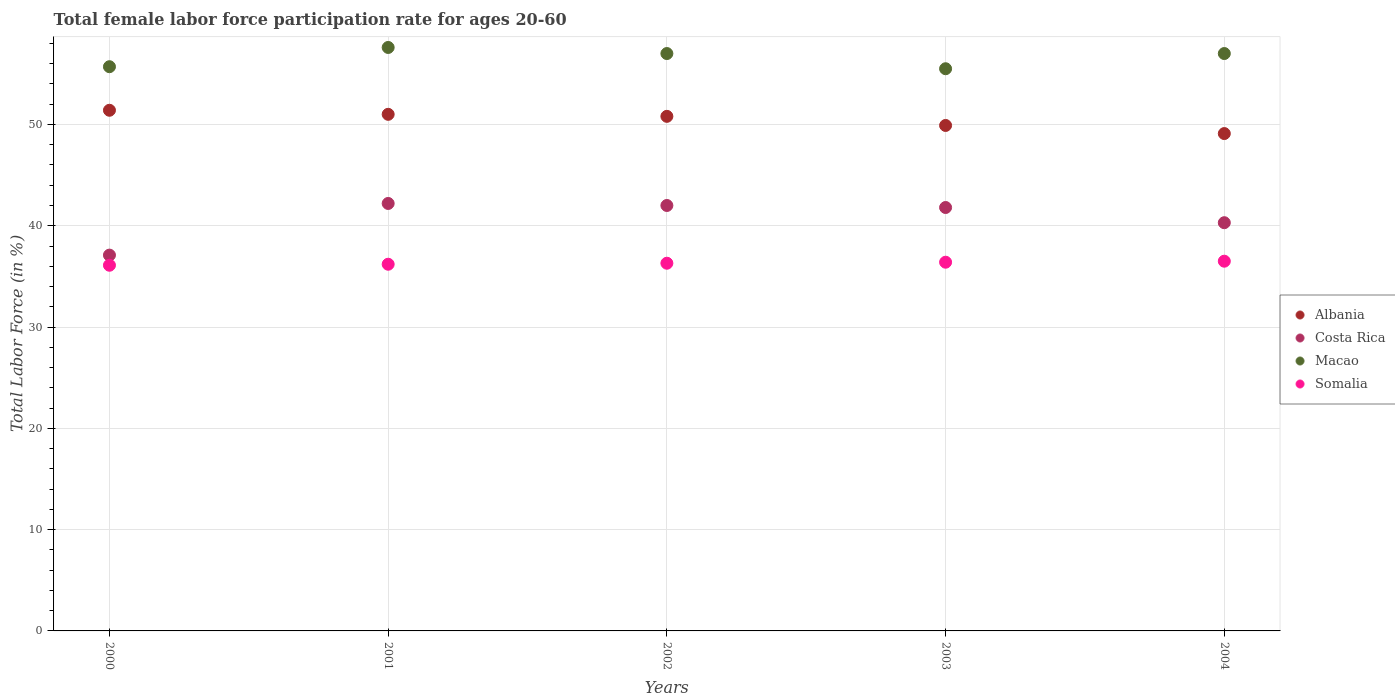Is the number of dotlines equal to the number of legend labels?
Provide a short and direct response. Yes. What is the female labor force participation rate in Costa Rica in 2004?
Provide a short and direct response. 40.3. Across all years, what is the maximum female labor force participation rate in Somalia?
Your answer should be very brief. 36.5. Across all years, what is the minimum female labor force participation rate in Macao?
Your answer should be compact. 55.5. What is the total female labor force participation rate in Albania in the graph?
Provide a succinct answer. 252.2. What is the difference between the female labor force participation rate in Costa Rica in 2002 and that in 2003?
Make the answer very short. 0.2. What is the difference between the female labor force participation rate in Albania in 2004 and the female labor force participation rate in Costa Rica in 2002?
Ensure brevity in your answer.  7.1. What is the average female labor force participation rate in Somalia per year?
Give a very brief answer. 36.3. In the year 2000, what is the difference between the female labor force participation rate in Somalia and female labor force participation rate in Albania?
Offer a terse response. -15.3. In how many years, is the female labor force participation rate in Albania greater than 56 %?
Your answer should be compact. 0. What is the ratio of the female labor force participation rate in Costa Rica in 2001 to that in 2003?
Keep it short and to the point. 1.01. Is the difference between the female labor force participation rate in Somalia in 2002 and 2003 greater than the difference between the female labor force participation rate in Albania in 2002 and 2003?
Ensure brevity in your answer.  No. What is the difference between the highest and the second highest female labor force participation rate in Somalia?
Ensure brevity in your answer.  0.1. What is the difference between the highest and the lowest female labor force participation rate in Albania?
Offer a terse response. 2.3. Is it the case that in every year, the sum of the female labor force participation rate in Albania and female labor force participation rate in Macao  is greater than the female labor force participation rate in Costa Rica?
Make the answer very short. Yes. Is the female labor force participation rate in Albania strictly greater than the female labor force participation rate in Costa Rica over the years?
Provide a short and direct response. Yes. How many years are there in the graph?
Ensure brevity in your answer.  5. What is the difference between two consecutive major ticks on the Y-axis?
Give a very brief answer. 10. Does the graph contain any zero values?
Offer a terse response. No. Where does the legend appear in the graph?
Provide a short and direct response. Center right. How many legend labels are there?
Keep it short and to the point. 4. How are the legend labels stacked?
Offer a very short reply. Vertical. What is the title of the graph?
Ensure brevity in your answer.  Total female labor force participation rate for ages 20-60. Does "Belgium" appear as one of the legend labels in the graph?
Your answer should be very brief. No. What is the label or title of the X-axis?
Your answer should be compact. Years. What is the Total Labor Force (in %) of Albania in 2000?
Offer a terse response. 51.4. What is the Total Labor Force (in %) of Costa Rica in 2000?
Keep it short and to the point. 37.1. What is the Total Labor Force (in %) in Macao in 2000?
Provide a succinct answer. 55.7. What is the Total Labor Force (in %) of Somalia in 2000?
Keep it short and to the point. 36.1. What is the Total Labor Force (in %) of Albania in 2001?
Offer a very short reply. 51. What is the Total Labor Force (in %) in Costa Rica in 2001?
Your response must be concise. 42.2. What is the Total Labor Force (in %) of Macao in 2001?
Provide a succinct answer. 57.6. What is the Total Labor Force (in %) in Somalia in 2001?
Provide a short and direct response. 36.2. What is the Total Labor Force (in %) in Albania in 2002?
Your response must be concise. 50.8. What is the Total Labor Force (in %) in Macao in 2002?
Give a very brief answer. 57. What is the Total Labor Force (in %) in Somalia in 2002?
Keep it short and to the point. 36.3. What is the Total Labor Force (in %) in Albania in 2003?
Keep it short and to the point. 49.9. What is the Total Labor Force (in %) in Costa Rica in 2003?
Keep it short and to the point. 41.8. What is the Total Labor Force (in %) in Macao in 2003?
Provide a short and direct response. 55.5. What is the Total Labor Force (in %) in Somalia in 2003?
Provide a succinct answer. 36.4. What is the Total Labor Force (in %) of Albania in 2004?
Provide a succinct answer. 49.1. What is the Total Labor Force (in %) in Costa Rica in 2004?
Your answer should be compact. 40.3. What is the Total Labor Force (in %) of Somalia in 2004?
Offer a very short reply. 36.5. Across all years, what is the maximum Total Labor Force (in %) of Albania?
Provide a short and direct response. 51.4. Across all years, what is the maximum Total Labor Force (in %) of Costa Rica?
Give a very brief answer. 42.2. Across all years, what is the maximum Total Labor Force (in %) of Macao?
Offer a very short reply. 57.6. Across all years, what is the maximum Total Labor Force (in %) in Somalia?
Your answer should be compact. 36.5. Across all years, what is the minimum Total Labor Force (in %) of Albania?
Give a very brief answer. 49.1. Across all years, what is the minimum Total Labor Force (in %) in Costa Rica?
Your answer should be compact. 37.1. Across all years, what is the minimum Total Labor Force (in %) in Macao?
Your answer should be compact. 55.5. Across all years, what is the minimum Total Labor Force (in %) in Somalia?
Offer a terse response. 36.1. What is the total Total Labor Force (in %) of Albania in the graph?
Your answer should be compact. 252.2. What is the total Total Labor Force (in %) of Costa Rica in the graph?
Your answer should be very brief. 203.4. What is the total Total Labor Force (in %) in Macao in the graph?
Offer a terse response. 282.8. What is the total Total Labor Force (in %) in Somalia in the graph?
Offer a terse response. 181.5. What is the difference between the Total Labor Force (in %) in Albania in 2000 and that in 2001?
Offer a terse response. 0.4. What is the difference between the Total Labor Force (in %) of Costa Rica in 2000 and that in 2001?
Your answer should be compact. -5.1. What is the difference between the Total Labor Force (in %) of Macao in 2000 and that in 2001?
Provide a succinct answer. -1.9. What is the difference between the Total Labor Force (in %) in Somalia in 2000 and that in 2001?
Your answer should be very brief. -0.1. What is the difference between the Total Labor Force (in %) of Albania in 2000 and that in 2002?
Your answer should be very brief. 0.6. What is the difference between the Total Labor Force (in %) in Somalia in 2000 and that in 2002?
Your answer should be compact. -0.2. What is the difference between the Total Labor Force (in %) of Costa Rica in 2000 and that in 2003?
Provide a short and direct response. -4.7. What is the difference between the Total Labor Force (in %) of Macao in 2000 and that in 2003?
Give a very brief answer. 0.2. What is the difference between the Total Labor Force (in %) of Albania in 2000 and that in 2004?
Your answer should be very brief. 2.3. What is the difference between the Total Labor Force (in %) of Costa Rica in 2000 and that in 2004?
Make the answer very short. -3.2. What is the difference between the Total Labor Force (in %) in Macao in 2000 and that in 2004?
Offer a terse response. -1.3. What is the difference between the Total Labor Force (in %) of Somalia in 2000 and that in 2004?
Ensure brevity in your answer.  -0.4. What is the difference between the Total Labor Force (in %) in Albania in 2001 and that in 2002?
Make the answer very short. 0.2. What is the difference between the Total Labor Force (in %) in Macao in 2001 and that in 2002?
Ensure brevity in your answer.  0.6. What is the difference between the Total Labor Force (in %) of Albania in 2001 and that in 2003?
Provide a succinct answer. 1.1. What is the difference between the Total Labor Force (in %) of Costa Rica in 2001 and that in 2003?
Make the answer very short. 0.4. What is the difference between the Total Labor Force (in %) of Macao in 2001 and that in 2003?
Your response must be concise. 2.1. What is the difference between the Total Labor Force (in %) of Somalia in 2001 and that in 2003?
Ensure brevity in your answer.  -0.2. What is the difference between the Total Labor Force (in %) of Costa Rica in 2001 and that in 2004?
Provide a short and direct response. 1.9. What is the difference between the Total Labor Force (in %) of Macao in 2001 and that in 2004?
Make the answer very short. 0.6. What is the difference between the Total Labor Force (in %) of Albania in 2002 and that in 2003?
Your response must be concise. 0.9. What is the difference between the Total Labor Force (in %) in Macao in 2002 and that in 2003?
Provide a succinct answer. 1.5. What is the difference between the Total Labor Force (in %) in Costa Rica in 2002 and that in 2004?
Your answer should be compact. 1.7. What is the difference between the Total Labor Force (in %) of Macao in 2002 and that in 2004?
Your answer should be compact. 0. What is the difference between the Total Labor Force (in %) in Albania in 2003 and that in 2004?
Make the answer very short. 0.8. What is the difference between the Total Labor Force (in %) in Somalia in 2003 and that in 2004?
Offer a terse response. -0.1. What is the difference between the Total Labor Force (in %) in Albania in 2000 and the Total Labor Force (in %) in Somalia in 2001?
Your answer should be compact. 15.2. What is the difference between the Total Labor Force (in %) of Costa Rica in 2000 and the Total Labor Force (in %) of Macao in 2001?
Your answer should be very brief. -20.5. What is the difference between the Total Labor Force (in %) of Costa Rica in 2000 and the Total Labor Force (in %) of Somalia in 2001?
Give a very brief answer. 0.9. What is the difference between the Total Labor Force (in %) of Albania in 2000 and the Total Labor Force (in %) of Costa Rica in 2002?
Provide a short and direct response. 9.4. What is the difference between the Total Labor Force (in %) of Albania in 2000 and the Total Labor Force (in %) of Macao in 2002?
Offer a very short reply. -5.6. What is the difference between the Total Labor Force (in %) in Costa Rica in 2000 and the Total Labor Force (in %) in Macao in 2002?
Your response must be concise. -19.9. What is the difference between the Total Labor Force (in %) in Macao in 2000 and the Total Labor Force (in %) in Somalia in 2002?
Your answer should be very brief. 19.4. What is the difference between the Total Labor Force (in %) of Albania in 2000 and the Total Labor Force (in %) of Costa Rica in 2003?
Provide a succinct answer. 9.6. What is the difference between the Total Labor Force (in %) of Albania in 2000 and the Total Labor Force (in %) of Macao in 2003?
Keep it short and to the point. -4.1. What is the difference between the Total Labor Force (in %) of Costa Rica in 2000 and the Total Labor Force (in %) of Macao in 2003?
Keep it short and to the point. -18.4. What is the difference between the Total Labor Force (in %) of Costa Rica in 2000 and the Total Labor Force (in %) of Somalia in 2003?
Offer a terse response. 0.7. What is the difference between the Total Labor Force (in %) in Macao in 2000 and the Total Labor Force (in %) in Somalia in 2003?
Offer a terse response. 19.3. What is the difference between the Total Labor Force (in %) of Albania in 2000 and the Total Labor Force (in %) of Costa Rica in 2004?
Offer a very short reply. 11.1. What is the difference between the Total Labor Force (in %) of Costa Rica in 2000 and the Total Labor Force (in %) of Macao in 2004?
Offer a terse response. -19.9. What is the difference between the Total Labor Force (in %) of Costa Rica in 2000 and the Total Labor Force (in %) of Somalia in 2004?
Your answer should be compact. 0.6. What is the difference between the Total Labor Force (in %) of Albania in 2001 and the Total Labor Force (in %) of Somalia in 2002?
Keep it short and to the point. 14.7. What is the difference between the Total Labor Force (in %) of Costa Rica in 2001 and the Total Labor Force (in %) of Macao in 2002?
Offer a very short reply. -14.8. What is the difference between the Total Labor Force (in %) in Macao in 2001 and the Total Labor Force (in %) in Somalia in 2002?
Provide a succinct answer. 21.3. What is the difference between the Total Labor Force (in %) in Albania in 2001 and the Total Labor Force (in %) in Costa Rica in 2003?
Provide a short and direct response. 9.2. What is the difference between the Total Labor Force (in %) of Albania in 2001 and the Total Labor Force (in %) of Somalia in 2003?
Your response must be concise. 14.6. What is the difference between the Total Labor Force (in %) in Costa Rica in 2001 and the Total Labor Force (in %) in Macao in 2003?
Ensure brevity in your answer.  -13.3. What is the difference between the Total Labor Force (in %) of Costa Rica in 2001 and the Total Labor Force (in %) of Somalia in 2003?
Offer a terse response. 5.8. What is the difference between the Total Labor Force (in %) in Macao in 2001 and the Total Labor Force (in %) in Somalia in 2003?
Your answer should be compact. 21.2. What is the difference between the Total Labor Force (in %) of Albania in 2001 and the Total Labor Force (in %) of Costa Rica in 2004?
Make the answer very short. 10.7. What is the difference between the Total Labor Force (in %) of Albania in 2001 and the Total Labor Force (in %) of Macao in 2004?
Provide a succinct answer. -6. What is the difference between the Total Labor Force (in %) in Albania in 2001 and the Total Labor Force (in %) in Somalia in 2004?
Your answer should be very brief. 14.5. What is the difference between the Total Labor Force (in %) in Costa Rica in 2001 and the Total Labor Force (in %) in Macao in 2004?
Ensure brevity in your answer.  -14.8. What is the difference between the Total Labor Force (in %) in Costa Rica in 2001 and the Total Labor Force (in %) in Somalia in 2004?
Provide a succinct answer. 5.7. What is the difference between the Total Labor Force (in %) of Macao in 2001 and the Total Labor Force (in %) of Somalia in 2004?
Offer a terse response. 21.1. What is the difference between the Total Labor Force (in %) in Albania in 2002 and the Total Labor Force (in %) in Costa Rica in 2003?
Provide a short and direct response. 9. What is the difference between the Total Labor Force (in %) of Albania in 2002 and the Total Labor Force (in %) of Macao in 2003?
Provide a short and direct response. -4.7. What is the difference between the Total Labor Force (in %) in Macao in 2002 and the Total Labor Force (in %) in Somalia in 2003?
Provide a short and direct response. 20.6. What is the difference between the Total Labor Force (in %) in Albania in 2002 and the Total Labor Force (in %) in Macao in 2004?
Ensure brevity in your answer.  -6.2. What is the difference between the Total Labor Force (in %) in Albania in 2002 and the Total Labor Force (in %) in Somalia in 2004?
Ensure brevity in your answer.  14.3. What is the difference between the Total Labor Force (in %) of Costa Rica in 2002 and the Total Labor Force (in %) of Macao in 2004?
Give a very brief answer. -15. What is the difference between the Total Labor Force (in %) of Macao in 2002 and the Total Labor Force (in %) of Somalia in 2004?
Your answer should be compact. 20.5. What is the difference between the Total Labor Force (in %) in Costa Rica in 2003 and the Total Labor Force (in %) in Macao in 2004?
Make the answer very short. -15.2. What is the average Total Labor Force (in %) of Albania per year?
Your response must be concise. 50.44. What is the average Total Labor Force (in %) of Costa Rica per year?
Your answer should be very brief. 40.68. What is the average Total Labor Force (in %) in Macao per year?
Provide a short and direct response. 56.56. What is the average Total Labor Force (in %) of Somalia per year?
Keep it short and to the point. 36.3. In the year 2000, what is the difference between the Total Labor Force (in %) of Albania and Total Labor Force (in %) of Costa Rica?
Your response must be concise. 14.3. In the year 2000, what is the difference between the Total Labor Force (in %) in Albania and Total Labor Force (in %) in Somalia?
Your answer should be compact. 15.3. In the year 2000, what is the difference between the Total Labor Force (in %) in Costa Rica and Total Labor Force (in %) in Macao?
Offer a terse response. -18.6. In the year 2000, what is the difference between the Total Labor Force (in %) of Costa Rica and Total Labor Force (in %) of Somalia?
Give a very brief answer. 1. In the year 2000, what is the difference between the Total Labor Force (in %) in Macao and Total Labor Force (in %) in Somalia?
Provide a succinct answer. 19.6. In the year 2001, what is the difference between the Total Labor Force (in %) of Albania and Total Labor Force (in %) of Macao?
Provide a short and direct response. -6.6. In the year 2001, what is the difference between the Total Labor Force (in %) in Albania and Total Labor Force (in %) in Somalia?
Keep it short and to the point. 14.8. In the year 2001, what is the difference between the Total Labor Force (in %) of Costa Rica and Total Labor Force (in %) of Macao?
Offer a terse response. -15.4. In the year 2001, what is the difference between the Total Labor Force (in %) in Macao and Total Labor Force (in %) in Somalia?
Offer a terse response. 21.4. In the year 2002, what is the difference between the Total Labor Force (in %) in Albania and Total Labor Force (in %) in Macao?
Give a very brief answer. -6.2. In the year 2002, what is the difference between the Total Labor Force (in %) in Albania and Total Labor Force (in %) in Somalia?
Provide a short and direct response. 14.5. In the year 2002, what is the difference between the Total Labor Force (in %) of Macao and Total Labor Force (in %) of Somalia?
Provide a succinct answer. 20.7. In the year 2003, what is the difference between the Total Labor Force (in %) of Costa Rica and Total Labor Force (in %) of Macao?
Ensure brevity in your answer.  -13.7. In the year 2004, what is the difference between the Total Labor Force (in %) of Costa Rica and Total Labor Force (in %) of Macao?
Give a very brief answer. -16.7. In the year 2004, what is the difference between the Total Labor Force (in %) of Macao and Total Labor Force (in %) of Somalia?
Make the answer very short. 20.5. What is the ratio of the Total Labor Force (in %) of Costa Rica in 2000 to that in 2001?
Keep it short and to the point. 0.88. What is the ratio of the Total Labor Force (in %) of Macao in 2000 to that in 2001?
Provide a succinct answer. 0.97. What is the ratio of the Total Labor Force (in %) of Albania in 2000 to that in 2002?
Provide a short and direct response. 1.01. What is the ratio of the Total Labor Force (in %) of Costa Rica in 2000 to that in 2002?
Keep it short and to the point. 0.88. What is the ratio of the Total Labor Force (in %) of Macao in 2000 to that in 2002?
Provide a short and direct response. 0.98. What is the ratio of the Total Labor Force (in %) of Somalia in 2000 to that in 2002?
Ensure brevity in your answer.  0.99. What is the ratio of the Total Labor Force (in %) of Albania in 2000 to that in 2003?
Give a very brief answer. 1.03. What is the ratio of the Total Labor Force (in %) of Costa Rica in 2000 to that in 2003?
Provide a succinct answer. 0.89. What is the ratio of the Total Labor Force (in %) in Macao in 2000 to that in 2003?
Offer a terse response. 1. What is the ratio of the Total Labor Force (in %) of Albania in 2000 to that in 2004?
Make the answer very short. 1.05. What is the ratio of the Total Labor Force (in %) in Costa Rica in 2000 to that in 2004?
Provide a succinct answer. 0.92. What is the ratio of the Total Labor Force (in %) of Macao in 2000 to that in 2004?
Give a very brief answer. 0.98. What is the ratio of the Total Labor Force (in %) in Albania in 2001 to that in 2002?
Provide a short and direct response. 1. What is the ratio of the Total Labor Force (in %) of Macao in 2001 to that in 2002?
Ensure brevity in your answer.  1.01. What is the ratio of the Total Labor Force (in %) in Albania in 2001 to that in 2003?
Provide a succinct answer. 1.02. What is the ratio of the Total Labor Force (in %) of Costa Rica in 2001 to that in 2003?
Keep it short and to the point. 1.01. What is the ratio of the Total Labor Force (in %) in Macao in 2001 to that in 2003?
Provide a succinct answer. 1.04. What is the ratio of the Total Labor Force (in %) of Somalia in 2001 to that in 2003?
Offer a terse response. 0.99. What is the ratio of the Total Labor Force (in %) of Albania in 2001 to that in 2004?
Offer a terse response. 1.04. What is the ratio of the Total Labor Force (in %) in Costa Rica in 2001 to that in 2004?
Your answer should be compact. 1.05. What is the ratio of the Total Labor Force (in %) in Macao in 2001 to that in 2004?
Provide a short and direct response. 1.01. What is the ratio of the Total Labor Force (in %) of Albania in 2002 to that in 2003?
Keep it short and to the point. 1.02. What is the ratio of the Total Labor Force (in %) in Costa Rica in 2002 to that in 2003?
Provide a short and direct response. 1. What is the ratio of the Total Labor Force (in %) in Somalia in 2002 to that in 2003?
Your answer should be compact. 1. What is the ratio of the Total Labor Force (in %) in Albania in 2002 to that in 2004?
Provide a short and direct response. 1.03. What is the ratio of the Total Labor Force (in %) in Costa Rica in 2002 to that in 2004?
Make the answer very short. 1.04. What is the ratio of the Total Labor Force (in %) in Somalia in 2002 to that in 2004?
Give a very brief answer. 0.99. What is the ratio of the Total Labor Force (in %) of Albania in 2003 to that in 2004?
Provide a short and direct response. 1.02. What is the ratio of the Total Labor Force (in %) of Costa Rica in 2003 to that in 2004?
Your answer should be very brief. 1.04. What is the ratio of the Total Labor Force (in %) in Macao in 2003 to that in 2004?
Provide a succinct answer. 0.97. What is the ratio of the Total Labor Force (in %) of Somalia in 2003 to that in 2004?
Provide a succinct answer. 1. What is the difference between the highest and the second highest Total Labor Force (in %) in Costa Rica?
Give a very brief answer. 0.2. What is the difference between the highest and the lowest Total Labor Force (in %) of Albania?
Offer a very short reply. 2.3. What is the difference between the highest and the lowest Total Labor Force (in %) of Macao?
Your answer should be compact. 2.1. What is the difference between the highest and the lowest Total Labor Force (in %) in Somalia?
Keep it short and to the point. 0.4. 